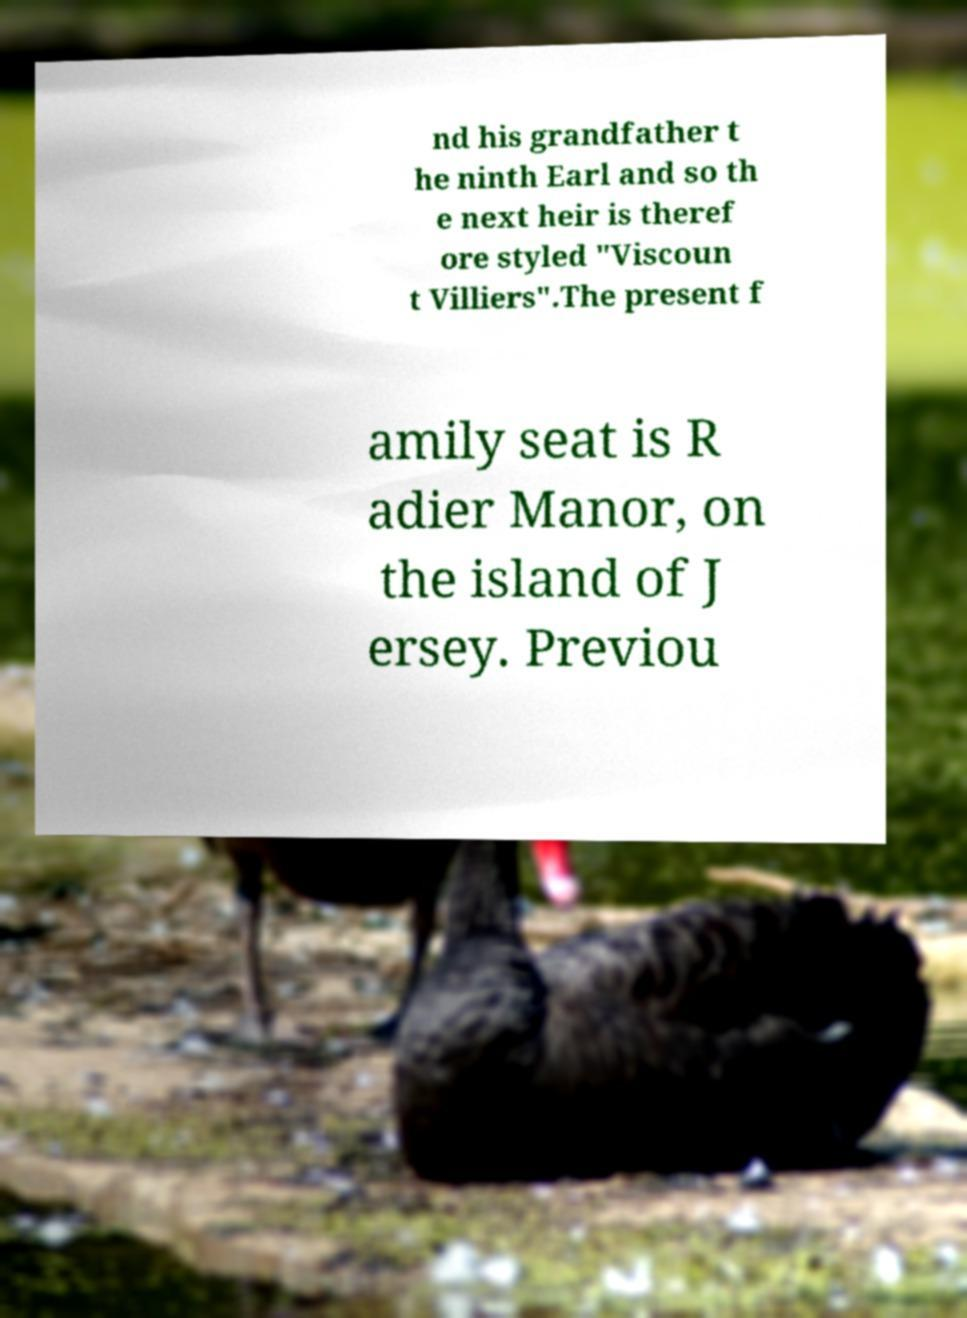What messages or text are displayed in this image? I need them in a readable, typed format. nd his grandfather t he ninth Earl and so th e next heir is theref ore styled "Viscoun t Villiers".The present f amily seat is R adier Manor, on the island of J ersey. Previou 